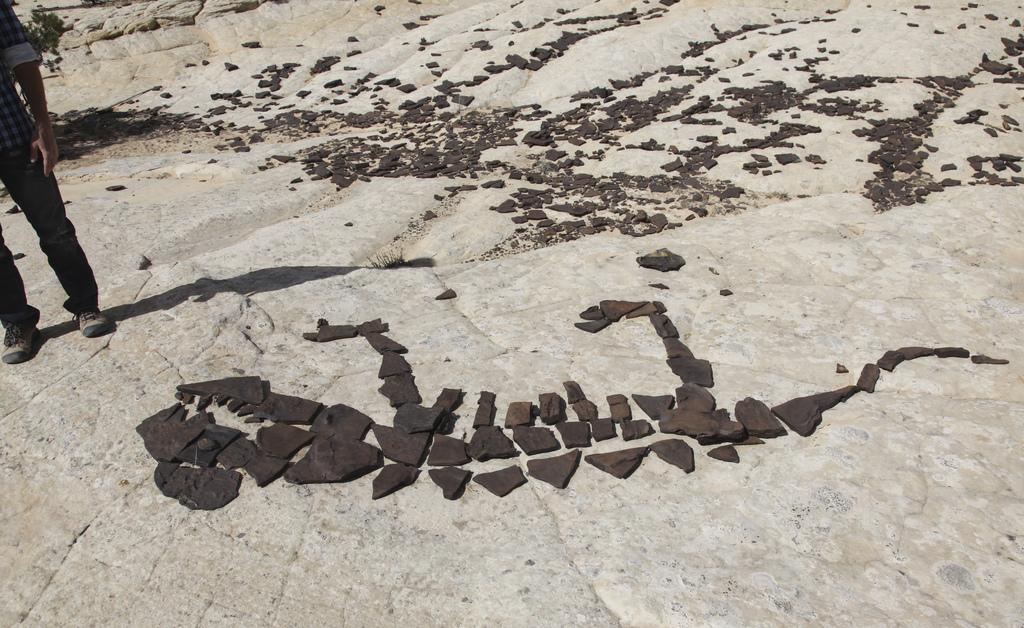What is located on the left side of the image? There is a person standing on the land on the left side of the image. What can be seen in the middle of the image? There are rocks in the middle of the image. What type of natural elements are present in the background of the image? There are stones on the land in the background of the image. How many ants can be seen crawling on the canvas in the image? There is no canvas or ants present in the image. What type of step is visible in the image? There is no step visible in the image; it features a person standing on land, rocks, and stones. 